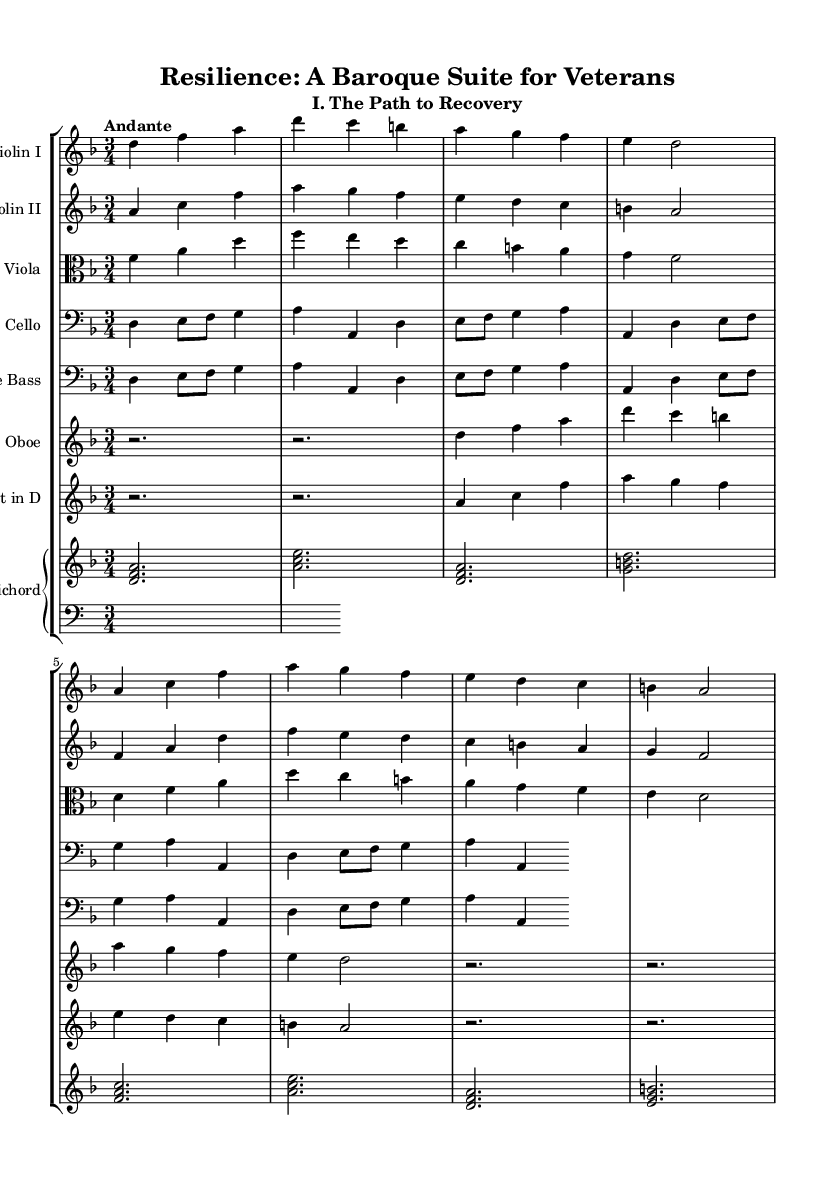what is the key signature of this music? The key signature is D minor, indicated by one flat (B flat) in the signature at the beginning of the staff.
Answer: D minor what is the time signature of this music? The time signature is 3/4, which means there are three beats in each measure and the quarter note gets one beat, as shown at the beginning of the score.
Answer: 3/4 what is the tempo marking of the piece? The tempo marking is "Andante," which typically indicates a moderately slow tempo, generally between 76 and 108 beats per minute, provided above the score.
Answer: Andante how many instruments are featured in this orchestral suite? The suite features eight instruments: two violins, one viola, one cello, one double bass, one oboe, one trumpet, and one harpsichord. This is evident from the staff listings at the beginning of the score.
Answer: Eight instruments what is the primary melodic instrument in this suite? The primary melodic instruments in this suite are the violins, which often carry the main melodic lines, as displayed in the score where their parts are notated prominently above the others.
Answer: Violins what texture is primarily used in this Baroque orchestral suite? The texture is predominantly homophonic, characterized by a clear melody accompanied by chords, which can be deduced from the layering of parts and the use of harmonized lines in the scoring.
Answer: Homophonic which instrument carries the bass line throughout the piece? The double bass carries the bass line, as indicated by its part, which consistently provides harmonic support and foundational pitches beneath the other voices.
Answer: Double bass 